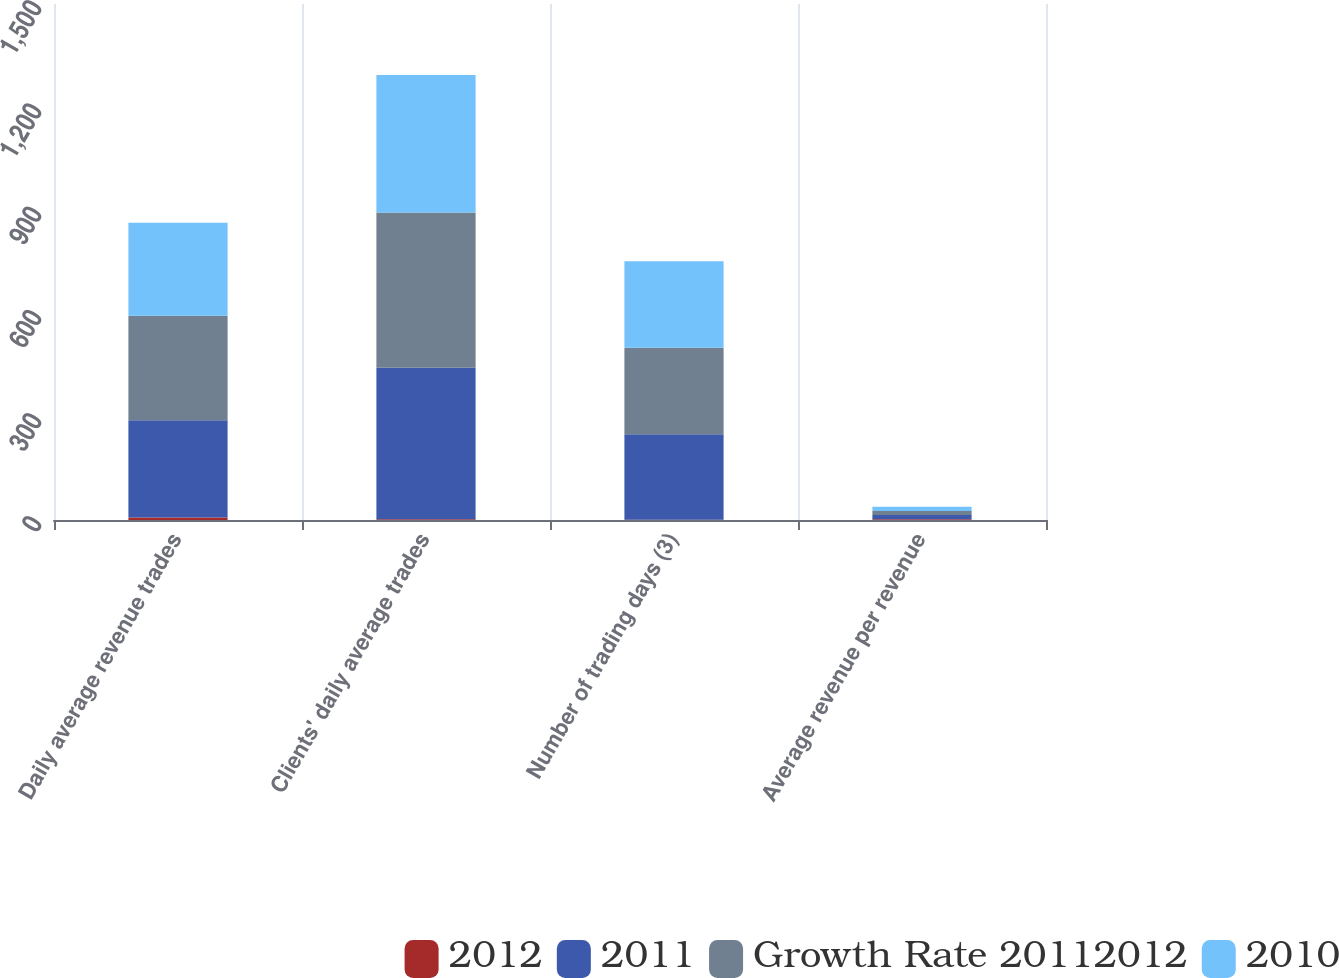Convert chart to OTSL. <chart><loc_0><loc_0><loc_500><loc_500><stacked_bar_chart><ecel><fcel>Daily average revenue trades<fcel>Clients' daily average trades<fcel>Number of trading days (3)<fcel>Average revenue per revenue<nl><fcel>2012<fcel>7<fcel>2<fcel>1<fcel>2<nl><fcel>2011<fcel>282.7<fcel>440.9<fcel>248.5<fcel>12.35<nl><fcel>Growth Rate 20112012<fcel>303.8<fcel>451.1<fcel>251.5<fcel>12.15<nl><fcel>2010<fcel>270.7<fcel>399.7<fcel>251.5<fcel>12.28<nl></chart> 